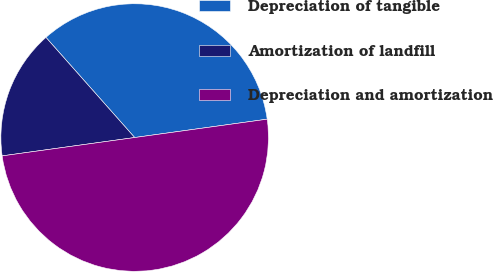Convert chart to OTSL. <chart><loc_0><loc_0><loc_500><loc_500><pie_chart><fcel>Depreciation of tangible<fcel>Amortization of landfill<fcel>Depreciation and amortization<nl><fcel>34.35%<fcel>15.65%<fcel>50.0%<nl></chart> 